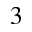Convert formula to latex. <formula><loc_0><loc_0><loc_500><loc_500>_ { 3 }</formula> 